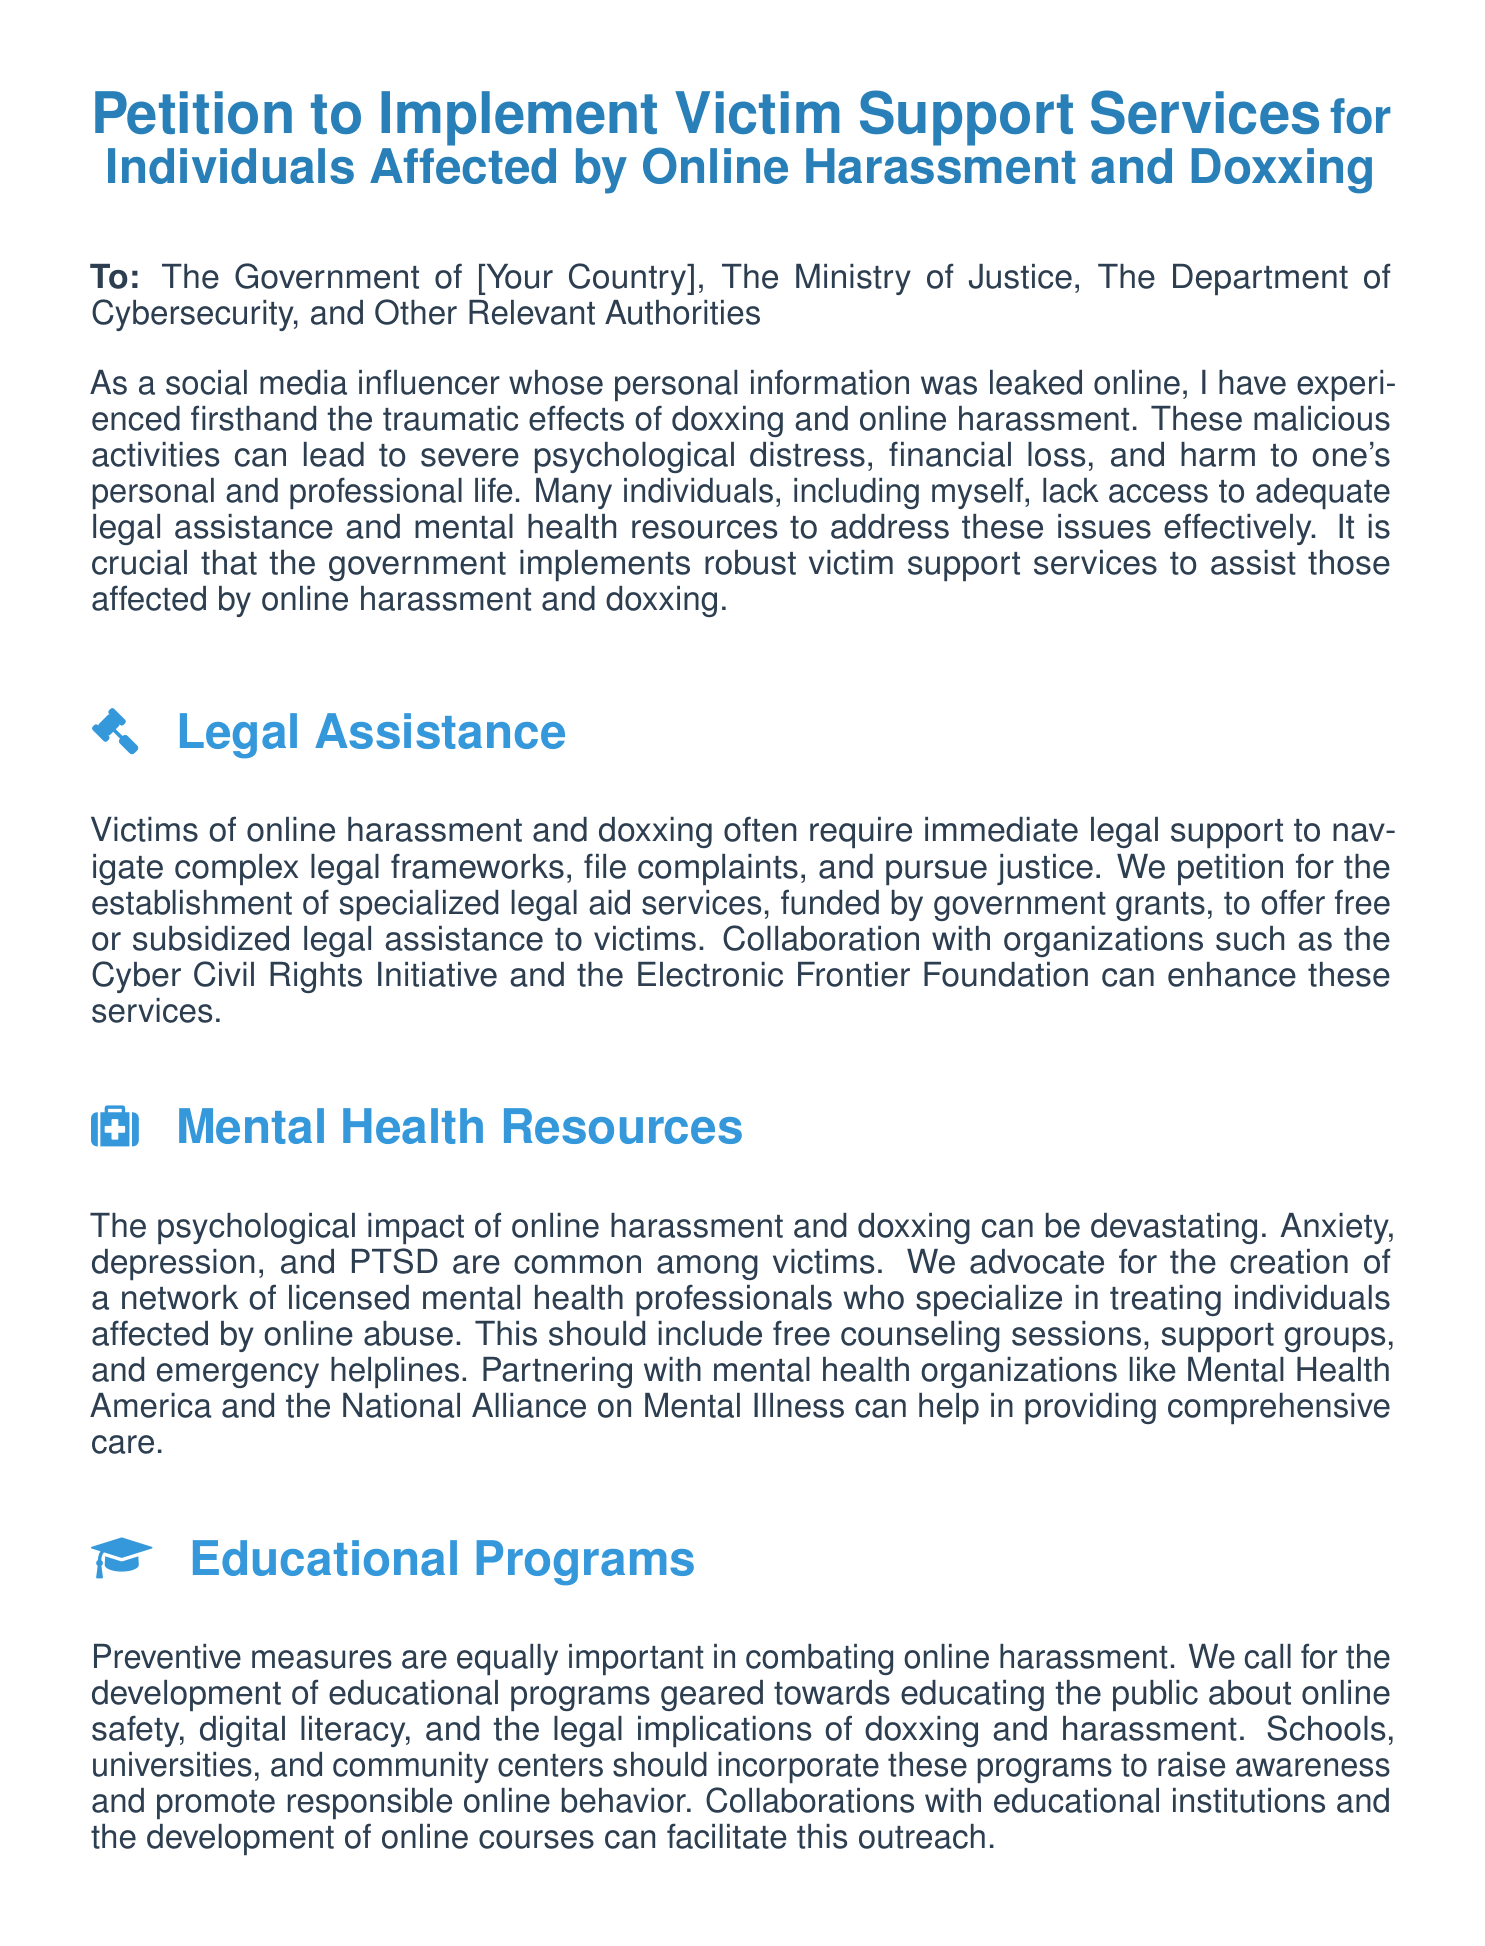What is the title of the petition? The title of the petition is listed at the top of the document, which specifies the purpose.
Answer: Petition to Implement Victim Support Services Who is the petition addressed to? The petition lists the recipients at the beginning, identifying the relevant authorities.
Answer: The Government of [Your Country], The Ministry of Justice, The Department of Cybersecurity, and Other Relevant Authorities What is one main component requested for victim support? The document outlines several critical areas for victim support services, one of which is highlighted.
Answer: Legal Assistance Which organization is mentioned as a collaborator for legal assistance? The petition names specific organizations that could enhance legal services for victims.
Answer: Cyber Civil Rights Initiative What mental health condition is commonly noted among victims? The document identifies specific psychological effects that individuals face due to online harassment.
Answer: Anxiety What type of educational initiatives are proposed? The document discusses the need for preventive measures through educational programs.
Answer: Educational Programs How should rapid response teams be trained? The petition suggests specific training for law enforcement to effectively address cybercrimes.
Answer: Trained to handle cybercrimes efficiently What is the main goal of the petition? The overarching aim of the petition is summarized in the final paragraphs of the document.
Answer: Implement comprehensive support services for victims 